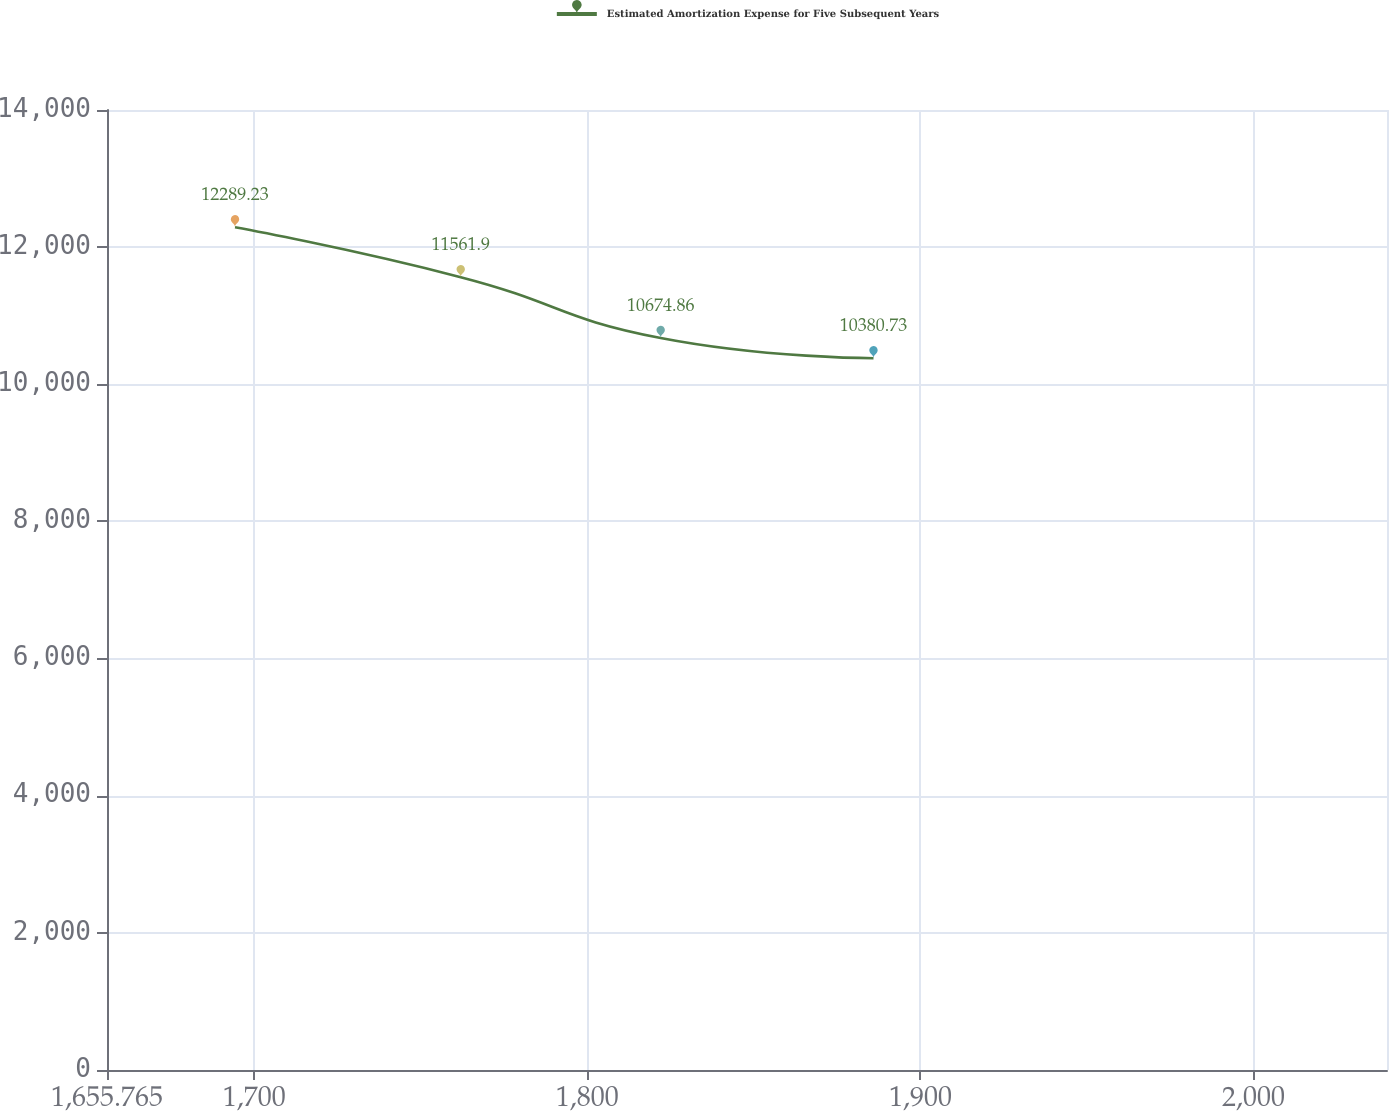<chart> <loc_0><loc_0><loc_500><loc_500><line_chart><ecel><fcel>Estimated Amortization Expense for Five Subsequent Years<nl><fcel>1694.2<fcel>12289.2<nl><fcel>1761.98<fcel>11561.9<nl><fcel>1822.02<fcel>10674.9<nl><fcel>1885.92<fcel>10380.7<nl><fcel>2078.55<fcel>13322<nl></chart> 